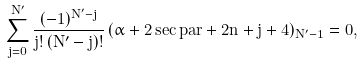<formula> <loc_0><loc_0><loc_500><loc_500>\sum _ { j = 0 } ^ { N ^ { \prime } } \frac { ( - 1 ) ^ { N ^ { \prime } - j } } { j ! \, ( N ^ { \prime } - j ) ! } \, ( \alpha + 2 \sec p a r + 2 n + j + 4 ) _ { N ^ { \prime } - 1 } = 0 ,</formula> 